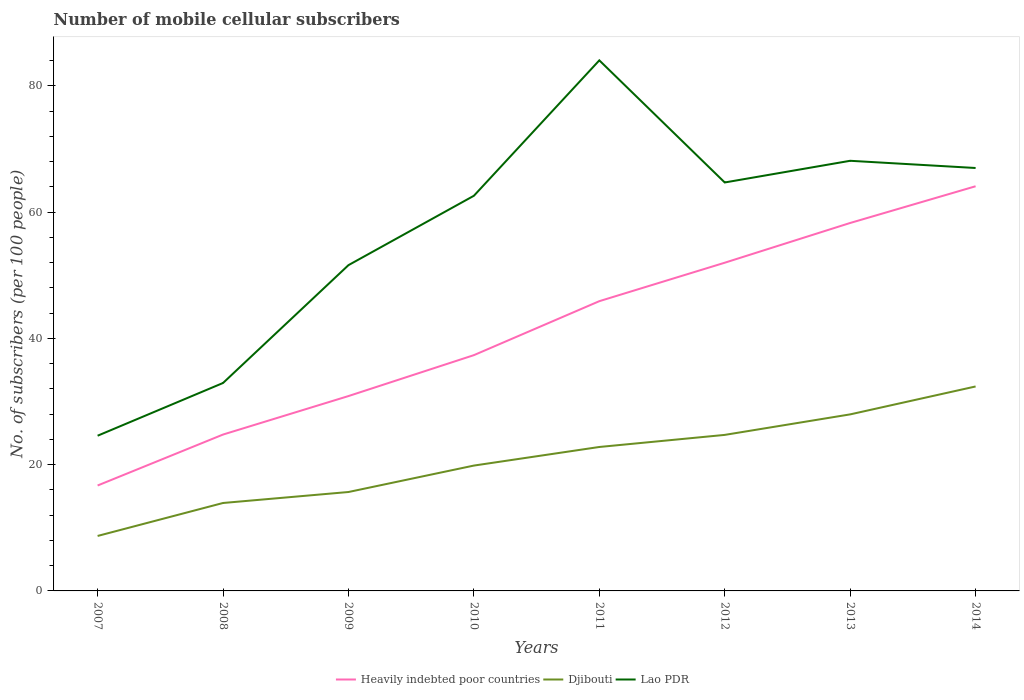Does the line corresponding to Heavily indebted poor countries intersect with the line corresponding to Lao PDR?
Your response must be concise. No. Across all years, what is the maximum number of mobile cellular subscribers in Heavily indebted poor countries?
Give a very brief answer. 16.7. What is the total number of mobile cellular subscribers in Heavily indebted poor countries in the graph?
Ensure brevity in your answer.  -39.33. What is the difference between the highest and the second highest number of mobile cellular subscribers in Djibouti?
Give a very brief answer. 23.68. What is the difference between the highest and the lowest number of mobile cellular subscribers in Heavily indebted poor countries?
Offer a terse response. 4. How many lines are there?
Your answer should be very brief. 3. How many legend labels are there?
Keep it short and to the point. 3. What is the title of the graph?
Your answer should be very brief. Number of mobile cellular subscribers. What is the label or title of the Y-axis?
Make the answer very short. No. of subscribers (per 100 people). What is the No. of subscribers (per 100 people) of Heavily indebted poor countries in 2007?
Your answer should be very brief. 16.7. What is the No. of subscribers (per 100 people) in Djibouti in 2007?
Offer a very short reply. 8.71. What is the No. of subscribers (per 100 people) of Lao PDR in 2007?
Ensure brevity in your answer.  24.59. What is the No. of subscribers (per 100 people) of Heavily indebted poor countries in 2008?
Your response must be concise. 24.77. What is the No. of subscribers (per 100 people) in Djibouti in 2008?
Your answer should be compact. 13.93. What is the No. of subscribers (per 100 people) of Lao PDR in 2008?
Provide a succinct answer. 32.94. What is the No. of subscribers (per 100 people) of Heavily indebted poor countries in 2009?
Offer a terse response. 30.87. What is the No. of subscribers (per 100 people) of Djibouti in 2009?
Keep it short and to the point. 15.67. What is the No. of subscribers (per 100 people) of Lao PDR in 2009?
Provide a succinct answer. 51.61. What is the No. of subscribers (per 100 people) in Heavily indebted poor countries in 2010?
Provide a short and direct response. 37.35. What is the No. of subscribers (per 100 people) of Djibouti in 2010?
Your answer should be very brief. 19.86. What is the No. of subscribers (per 100 people) in Lao PDR in 2010?
Provide a succinct answer. 62.59. What is the No. of subscribers (per 100 people) of Heavily indebted poor countries in 2011?
Provide a short and direct response. 45.9. What is the No. of subscribers (per 100 people) of Djibouti in 2011?
Ensure brevity in your answer.  22.8. What is the No. of subscribers (per 100 people) of Lao PDR in 2011?
Keep it short and to the point. 84.05. What is the No. of subscribers (per 100 people) of Heavily indebted poor countries in 2012?
Provide a short and direct response. 51.99. What is the No. of subscribers (per 100 people) of Djibouti in 2012?
Give a very brief answer. 24.72. What is the No. of subscribers (per 100 people) in Lao PDR in 2012?
Make the answer very short. 64.7. What is the No. of subscribers (per 100 people) of Heavily indebted poor countries in 2013?
Provide a short and direct response. 58.28. What is the No. of subscribers (per 100 people) in Djibouti in 2013?
Make the answer very short. 27.97. What is the No. of subscribers (per 100 people) of Lao PDR in 2013?
Keep it short and to the point. 68.14. What is the No. of subscribers (per 100 people) in Heavily indebted poor countries in 2014?
Give a very brief answer. 64.1. What is the No. of subscribers (per 100 people) in Djibouti in 2014?
Your answer should be very brief. 32.39. What is the No. of subscribers (per 100 people) of Lao PDR in 2014?
Provide a short and direct response. 66.99. Across all years, what is the maximum No. of subscribers (per 100 people) in Heavily indebted poor countries?
Provide a succinct answer. 64.1. Across all years, what is the maximum No. of subscribers (per 100 people) in Djibouti?
Your answer should be very brief. 32.39. Across all years, what is the maximum No. of subscribers (per 100 people) of Lao PDR?
Your response must be concise. 84.05. Across all years, what is the minimum No. of subscribers (per 100 people) of Heavily indebted poor countries?
Your answer should be very brief. 16.7. Across all years, what is the minimum No. of subscribers (per 100 people) of Djibouti?
Ensure brevity in your answer.  8.71. Across all years, what is the minimum No. of subscribers (per 100 people) in Lao PDR?
Offer a very short reply. 24.59. What is the total No. of subscribers (per 100 people) of Heavily indebted poor countries in the graph?
Offer a terse response. 329.96. What is the total No. of subscribers (per 100 people) of Djibouti in the graph?
Offer a terse response. 166.03. What is the total No. of subscribers (per 100 people) of Lao PDR in the graph?
Provide a short and direct response. 455.6. What is the difference between the No. of subscribers (per 100 people) of Heavily indebted poor countries in 2007 and that in 2008?
Ensure brevity in your answer.  -8.07. What is the difference between the No. of subscribers (per 100 people) of Djibouti in 2007 and that in 2008?
Keep it short and to the point. -5.22. What is the difference between the No. of subscribers (per 100 people) in Lao PDR in 2007 and that in 2008?
Your answer should be compact. -8.35. What is the difference between the No. of subscribers (per 100 people) in Heavily indebted poor countries in 2007 and that in 2009?
Your answer should be compact. -14.17. What is the difference between the No. of subscribers (per 100 people) of Djibouti in 2007 and that in 2009?
Your answer should be very brief. -6.96. What is the difference between the No. of subscribers (per 100 people) in Lao PDR in 2007 and that in 2009?
Make the answer very short. -27.02. What is the difference between the No. of subscribers (per 100 people) in Heavily indebted poor countries in 2007 and that in 2010?
Offer a terse response. -20.65. What is the difference between the No. of subscribers (per 100 people) of Djibouti in 2007 and that in 2010?
Make the answer very short. -11.15. What is the difference between the No. of subscribers (per 100 people) in Lao PDR in 2007 and that in 2010?
Ensure brevity in your answer.  -38.01. What is the difference between the No. of subscribers (per 100 people) in Heavily indebted poor countries in 2007 and that in 2011?
Give a very brief answer. -29.2. What is the difference between the No. of subscribers (per 100 people) of Djibouti in 2007 and that in 2011?
Keep it short and to the point. -14.1. What is the difference between the No. of subscribers (per 100 people) of Lao PDR in 2007 and that in 2011?
Give a very brief answer. -59.46. What is the difference between the No. of subscribers (per 100 people) of Heavily indebted poor countries in 2007 and that in 2012?
Provide a succinct answer. -35.29. What is the difference between the No. of subscribers (per 100 people) of Djibouti in 2007 and that in 2012?
Provide a succinct answer. -16.01. What is the difference between the No. of subscribers (per 100 people) of Lao PDR in 2007 and that in 2012?
Your answer should be very brief. -40.12. What is the difference between the No. of subscribers (per 100 people) of Heavily indebted poor countries in 2007 and that in 2013?
Provide a short and direct response. -41.59. What is the difference between the No. of subscribers (per 100 people) of Djibouti in 2007 and that in 2013?
Provide a succinct answer. -19.26. What is the difference between the No. of subscribers (per 100 people) in Lao PDR in 2007 and that in 2013?
Offer a terse response. -43.55. What is the difference between the No. of subscribers (per 100 people) of Heavily indebted poor countries in 2007 and that in 2014?
Your response must be concise. -47.4. What is the difference between the No. of subscribers (per 100 people) in Djibouti in 2007 and that in 2014?
Offer a terse response. -23.68. What is the difference between the No. of subscribers (per 100 people) of Lao PDR in 2007 and that in 2014?
Give a very brief answer. -42.41. What is the difference between the No. of subscribers (per 100 people) of Heavily indebted poor countries in 2008 and that in 2009?
Offer a terse response. -6.1. What is the difference between the No. of subscribers (per 100 people) of Djibouti in 2008 and that in 2009?
Your response must be concise. -1.74. What is the difference between the No. of subscribers (per 100 people) in Lao PDR in 2008 and that in 2009?
Ensure brevity in your answer.  -18.67. What is the difference between the No. of subscribers (per 100 people) in Heavily indebted poor countries in 2008 and that in 2010?
Make the answer very short. -12.58. What is the difference between the No. of subscribers (per 100 people) of Djibouti in 2008 and that in 2010?
Keep it short and to the point. -5.93. What is the difference between the No. of subscribers (per 100 people) of Lao PDR in 2008 and that in 2010?
Offer a very short reply. -29.66. What is the difference between the No. of subscribers (per 100 people) of Heavily indebted poor countries in 2008 and that in 2011?
Keep it short and to the point. -21.13. What is the difference between the No. of subscribers (per 100 people) of Djibouti in 2008 and that in 2011?
Offer a terse response. -8.87. What is the difference between the No. of subscribers (per 100 people) of Lao PDR in 2008 and that in 2011?
Ensure brevity in your answer.  -51.11. What is the difference between the No. of subscribers (per 100 people) in Heavily indebted poor countries in 2008 and that in 2012?
Keep it short and to the point. -27.22. What is the difference between the No. of subscribers (per 100 people) of Djibouti in 2008 and that in 2012?
Your response must be concise. -10.79. What is the difference between the No. of subscribers (per 100 people) in Lao PDR in 2008 and that in 2012?
Offer a very short reply. -31.76. What is the difference between the No. of subscribers (per 100 people) in Heavily indebted poor countries in 2008 and that in 2013?
Ensure brevity in your answer.  -33.51. What is the difference between the No. of subscribers (per 100 people) of Djibouti in 2008 and that in 2013?
Keep it short and to the point. -14.04. What is the difference between the No. of subscribers (per 100 people) of Lao PDR in 2008 and that in 2013?
Your response must be concise. -35.2. What is the difference between the No. of subscribers (per 100 people) in Heavily indebted poor countries in 2008 and that in 2014?
Ensure brevity in your answer.  -39.33. What is the difference between the No. of subscribers (per 100 people) in Djibouti in 2008 and that in 2014?
Make the answer very short. -18.46. What is the difference between the No. of subscribers (per 100 people) of Lao PDR in 2008 and that in 2014?
Your answer should be compact. -34.05. What is the difference between the No. of subscribers (per 100 people) in Heavily indebted poor countries in 2009 and that in 2010?
Provide a short and direct response. -6.48. What is the difference between the No. of subscribers (per 100 people) of Djibouti in 2009 and that in 2010?
Give a very brief answer. -4.19. What is the difference between the No. of subscribers (per 100 people) of Lao PDR in 2009 and that in 2010?
Your answer should be compact. -10.99. What is the difference between the No. of subscribers (per 100 people) in Heavily indebted poor countries in 2009 and that in 2011?
Offer a terse response. -15.03. What is the difference between the No. of subscribers (per 100 people) of Djibouti in 2009 and that in 2011?
Keep it short and to the point. -7.13. What is the difference between the No. of subscribers (per 100 people) of Lao PDR in 2009 and that in 2011?
Your answer should be very brief. -32.44. What is the difference between the No. of subscribers (per 100 people) of Heavily indebted poor countries in 2009 and that in 2012?
Provide a succinct answer. -21.12. What is the difference between the No. of subscribers (per 100 people) of Djibouti in 2009 and that in 2012?
Keep it short and to the point. -9.05. What is the difference between the No. of subscribers (per 100 people) of Lao PDR in 2009 and that in 2012?
Offer a terse response. -13.1. What is the difference between the No. of subscribers (per 100 people) of Heavily indebted poor countries in 2009 and that in 2013?
Make the answer very short. -27.42. What is the difference between the No. of subscribers (per 100 people) in Djibouti in 2009 and that in 2013?
Make the answer very short. -12.3. What is the difference between the No. of subscribers (per 100 people) of Lao PDR in 2009 and that in 2013?
Your answer should be compact. -16.53. What is the difference between the No. of subscribers (per 100 people) in Heavily indebted poor countries in 2009 and that in 2014?
Keep it short and to the point. -33.23. What is the difference between the No. of subscribers (per 100 people) of Djibouti in 2009 and that in 2014?
Make the answer very short. -16.72. What is the difference between the No. of subscribers (per 100 people) of Lao PDR in 2009 and that in 2014?
Give a very brief answer. -15.39. What is the difference between the No. of subscribers (per 100 people) in Heavily indebted poor countries in 2010 and that in 2011?
Keep it short and to the point. -8.55. What is the difference between the No. of subscribers (per 100 people) in Djibouti in 2010 and that in 2011?
Make the answer very short. -2.94. What is the difference between the No. of subscribers (per 100 people) of Lao PDR in 2010 and that in 2011?
Ensure brevity in your answer.  -21.45. What is the difference between the No. of subscribers (per 100 people) in Heavily indebted poor countries in 2010 and that in 2012?
Keep it short and to the point. -14.64. What is the difference between the No. of subscribers (per 100 people) of Djibouti in 2010 and that in 2012?
Keep it short and to the point. -4.86. What is the difference between the No. of subscribers (per 100 people) of Lao PDR in 2010 and that in 2012?
Give a very brief answer. -2.11. What is the difference between the No. of subscribers (per 100 people) of Heavily indebted poor countries in 2010 and that in 2013?
Your answer should be compact. -20.94. What is the difference between the No. of subscribers (per 100 people) in Djibouti in 2010 and that in 2013?
Provide a short and direct response. -8.11. What is the difference between the No. of subscribers (per 100 people) of Lao PDR in 2010 and that in 2013?
Make the answer very short. -5.54. What is the difference between the No. of subscribers (per 100 people) in Heavily indebted poor countries in 2010 and that in 2014?
Offer a terse response. -26.75. What is the difference between the No. of subscribers (per 100 people) of Djibouti in 2010 and that in 2014?
Offer a very short reply. -12.53. What is the difference between the No. of subscribers (per 100 people) in Lao PDR in 2010 and that in 2014?
Your answer should be compact. -4.4. What is the difference between the No. of subscribers (per 100 people) in Heavily indebted poor countries in 2011 and that in 2012?
Your response must be concise. -6.09. What is the difference between the No. of subscribers (per 100 people) of Djibouti in 2011 and that in 2012?
Offer a very short reply. -1.91. What is the difference between the No. of subscribers (per 100 people) in Lao PDR in 2011 and that in 2012?
Offer a terse response. 19.34. What is the difference between the No. of subscribers (per 100 people) in Heavily indebted poor countries in 2011 and that in 2013?
Your answer should be very brief. -12.39. What is the difference between the No. of subscribers (per 100 people) of Djibouti in 2011 and that in 2013?
Your response must be concise. -5.16. What is the difference between the No. of subscribers (per 100 people) in Lao PDR in 2011 and that in 2013?
Provide a succinct answer. 15.91. What is the difference between the No. of subscribers (per 100 people) in Heavily indebted poor countries in 2011 and that in 2014?
Make the answer very short. -18.2. What is the difference between the No. of subscribers (per 100 people) of Djibouti in 2011 and that in 2014?
Provide a succinct answer. -9.59. What is the difference between the No. of subscribers (per 100 people) of Lao PDR in 2011 and that in 2014?
Ensure brevity in your answer.  17.05. What is the difference between the No. of subscribers (per 100 people) in Heavily indebted poor countries in 2012 and that in 2013?
Keep it short and to the point. -6.3. What is the difference between the No. of subscribers (per 100 people) of Djibouti in 2012 and that in 2013?
Offer a very short reply. -3.25. What is the difference between the No. of subscribers (per 100 people) in Lao PDR in 2012 and that in 2013?
Your answer should be compact. -3.43. What is the difference between the No. of subscribers (per 100 people) of Heavily indebted poor countries in 2012 and that in 2014?
Provide a succinct answer. -12.11. What is the difference between the No. of subscribers (per 100 people) of Djibouti in 2012 and that in 2014?
Give a very brief answer. -7.67. What is the difference between the No. of subscribers (per 100 people) of Lao PDR in 2012 and that in 2014?
Ensure brevity in your answer.  -2.29. What is the difference between the No. of subscribers (per 100 people) in Heavily indebted poor countries in 2013 and that in 2014?
Keep it short and to the point. -5.82. What is the difference between the No. of subscribers (per 100 people) in Djibouti in 2013 and that in 2014?
Provide a succinct answer. -4.42. What is the difference between the No. of subscribers (per 100 people) of Lao PDR in 2013 and that in 2014?
Offer a very short reply. 1.14. What is the difference between the No. of subscribers (per 100 people) of Heavily indebted poor countries in 2007 and the No. of subscribers (per 100 people) of Djibouti in 2008?
Give a very brief answer. 2.77. What is the difference between the No. of subscribers (per 100 people) in Heavily indebted poor countries in 2007 and the No. of subscribers (per 100 people) in Lao PDR in 2008?
Your answer should be very brief. -16.24. What is the difference between the No. of subscribers (per 100 people) of Djibouti in 2007 and the No. of subscribers (per 100 people) of Lao PDR in 2008?
Keep it short and to the point. -24.23. What is the difference between the No. of subscribers (per 100 people) in Heavily indebted poor countries in 2007 and the No. of subscribers (per 100 people) in Djibouti in 2009?
Make the answer very short. 1.03. What is the difference between the No. of subscribers (per 100 people) of Heavily indebted poor countries in 2007 and the No. of subscribers (per 100 people) of Lao PDR in 2009?
Keep it short and to the point. -34.91. What is the difference between the No. of subscribers (per 100 people) in Djibouti in 2007 and the No. of subscribers (per 100 people) in Lao PDR in 2009?
Give a very brief answer. -42.9. What is the difference between the No. of subscribers (per 100 people) in Heavily indebted poor countries in 2007 and the No. of subscribers (per 100 people) in Djibouti in 2010?
Provide a succinct answer. -3.16. What is the difference between the No. of subscribers (per 100 people) of Heavily indebted poor countries in 2007 and the No. of subscribers (per 100 people) of Lao PDR in 2010?
Offer a terse response. -45.9. What is the difference between the No. of subscribers (per 100 people) in Djibouti in 2007 and the No. of subscribers (per 100 people) in Lao PDR in 2010?
Your response must be concise. -53.89. What is the difference between the No. of subscribers (per 100 people) of Heavily indebted poor countries in 2007 and the No. of subscribers (per 100 people) of Djibouti in 2011?
Your answer should be compact. -6.1. What is the difference between the No. of subscribers (per 100 people) in Heavily indebted poor countries in 2007 and the No. of subscribers (per 100 people) in Lao PDR in 2011?
Keep it short and to the point. -67.35. What is the difference between the No. of subscribers (per 100 people) in Djibouti in 2007 and the No. of subscribers (per 100 people) in Lao PDR in 2011?
Ensure brevity in your answer.  -75.34. What is the difference between the No. of subscribers (per 100 people) of Heavily indebted poor countries in 2007 and the No. of subscribers (per 100 people) of Djibouti in 2012?
Your answer should be compact. -8.02. What is the difference between the No. of subscribers (per 100 people) in Heavily indebted poor countries in 2007 and the No. of subscribers (per 100 people) in Lao PDR in 2012?
Provide a succinct answer. -48. What is the difference between the No. of subscribers (per 100 people) in Djibouti in 2007 and the No. of subscribers (per 100 people) in Lao PDR in 2012?
Offer a terse response. -56. What is the difference between the No. of subscribers (per 100 people) of Heavily indebted poor countries in 2007 and the No. of subscribers (per 100 people) of Djibouti in 2013?
Ensure brevity in your answer.  -11.27. What is the difference between the No. of subscribers (per 100 people) in Heavily indebted poor countries in 2007 and the No. of subscribers (per 100 people) in Lao PDR in 2013?
Give a very brief answer. -51.44. What is the difference between the No. of subscribers (per 100 people) in Djibouti in 2007 and the No. of subscribers (per 100 people) in Lao PDR in 2013?
Provide a short and direct response. -59.43. What is the difference between the No. of subscribers (per 100 people) of Heavily indebted poor countries in 2007 and the No. of subscribers (per 100 people) of Djibouti in 2014?
Give a very brief answer. -15.69. What is the difference between the No. of subscribers (per 100 people) of Heavily indebted poor countries in 2007 and the No. of subscribers (per 100 people) of Lao PDR in 2014?
Offer a very short reply. -50.29. What is the difference between the No. of subscribers (per 100 people) of Djibouti in 2007 and the No. of subscribers (per 100 people) of Lao PDR in 2014?
Your response must be concise. -58.29. What is the difference between the No. of subscribers (per 100 people) of Heavily indebted poor countries in 2008 and the No. of subscribers (per 100 people) of Djibouti in 2009?
Keep it short and to the point. 9.1. What is the difference between the No. of subscribers (per 100 people) in Heavily indebted poor countries in 2008 and the No. of subscribers (per 100 people) in Lao PDR in 2009?
Offer a very short reply. -26.84. What is the difference between the No. of subscribers (per 100 people) in Djibouti in 2008 and the No. of subscribers (per 100 people) in Lao PDR in 2009?
Your answer should be very brief. -37.68. What is the difference between the No. of subscribers (per 100 people) of Heavily indebted poor countries in 2008 and the No. of subscribers (per 100 people) of Djibouti in 2010?
Provide a succinct answer. 4.91. What is the difference between the No. of subscribers (per 100 people) of Heavily indebted poor countries in 2008 and the No. of subscribers (per 100 people) of Lao PDR in 2010?
Provide a succinct answer. -37.82. What is the difference between the No. of subscribers (per 100 people) of Djibouti in 2008 and the No. of subscribers (per 100 people) of Lao PDR in 2010?
Provide a short and direct response. -48.66. What is the difference between the No. of subscribers (per 100 people) in Heavily indebted poor countries in 2008 and the No. of subscribers (per 100 people) in Djibouti in 2011?
Keep it short and to the point. 1.97. What is the difference between the No. of subscribers (per 100 people) in Heavily indebted poor countries in 2008 and the No. of subscribers (per 100 people) in Lao PDR in 2011?
Your answer should be compact. -59.27. What is the difference between the No. of subscribers (per 100 people) of Djibouti in 2008 and the No. of subscribers (per 100 people) of Lao PDR in 2011?
Your answer should be very brief. -70.12. What is the difference between the No. of subscribers (per 100 people) in Heavily indebted poor countries in 2008 and the No. of subscribers (per 100 people) in Djibouti in 2012?
Ensure brevity in your answer.  0.05. What is the difference between the No. of subscribers (per 100 people) of Heavily indebted poor countries in 2008 and the No. of subscribers (per 100 people) of Lao PDR in 2012?
Your answer should be compact. -39.93. What is the difference between the No. of subscribers (per 100 people) in Djibouti in 2008 and the No. of subscribers (per 100 people) in Lao PDR in 2012?
Your answer should be compact. -50.77. What is the difference between the No. of subscribers (per 100 people) of Heavily indebted poor countries in 2008 and the No. of subscribers (per 100 people) of Djibouti in 2013?
Your response must be concise. -3.2. What is the difference between the No. of subscribers (per 100 people) of Heavily indebted poor countries in 2008 and the No. of subscribers (per 100 people) of Lao PDR in 2013?
Ensure brevity in your answer.  -43.37. What is the difference between the No. of subscribers (per 100 people) in Djibouti in 2008 and the No. of subscribers (per 100 people) in Lao PDR in 2013?
Ensure brevity in your answer.  -54.21. What is the difference between the No. of subscribers (per 100 people) of Heavily indebted poor countries in 2008 and the No. of subscribers (per 100 people) of Djibouti in 2014?
Provide a short and direct response. -7.62. What is the difference between the No. of subscribers (per 100 people) of Heavily indebted poor countries in 2008 and the No. of subscribers (per 100 people) of Lao PDR in 2014?
Offer a very short reply. -42.22. What is the difference between the No. of subscribers (per 100 people) of Djibouti in 2008 and the No. of subscribers (per 100 people) of Lao PDR in 2014?
Make the answer very short. -53.06. What is the difference between the No. of subscribers (per 100 people) in Heavily indebted poor countries in 2009 and the No. of subscribers (per 100 people) in Djibouti in 2010?
Ensure brevity in your answer.  11.01. What is the difference between the No. of subscribers (per 100 people) in Heavily indebted poor countries in 2009 and the No. of subscribers (per 100 people) in Lao PDR in 2010?
Offer a terse response. -31.73. What is the difference between the No. of subscribers (per 100 people) of Djibouti in 2009 and the No. of subscribers (per 100 people) of Lao PDR in 2010?
Your answer should be very brief. -46.93. What is the difference between the No. of subscribers (per 100 people) of Heavily indebted poor countries in 2009 and the No. of subscribers (per 100 people) of Djibouti in 2011?
Give a very brief answer. 8.07. What is the difference between the No. of subscribers (per 100 people) of Heavily indebted poor countries in 2009 and the No. of subscribers (per 100 people) of Lao PDR in 2011?
Keep it short and to the point. -53.18. What is the difference between the No. of subscribers (per 100 people) in Djibouti in 2009 and the No. of subscribers (per 100 people) in Lao PDR in 2011?
Ensure brevity in your answer.  -68.38. What is the difference between the No. of subscribers (per 100 people) of Heavily indebted poor countries in 2009 and the No. of subscribers (per 100 people) of Djibouti in 2012?
Your response must be concise. 6.15. What is the difference between the No. of subscribers (per 100 people) in Heavily indebted poor countries in 2009 and the No. of subscribers (per 100 people) in Lao PDR in 2012?
Your answer should be compact. -33.83. What is the difference between the No. of subscribers (per 100 people) in Djibouti in 2009 and the No. of subscribers (per 100 people) in Lao PDR in 2012?
Provide a succinct answer. -49.03. What is the difference between the No. of subscribers (per 100 people) of Heavily indebted poor countries in 2009 and the No. of subscribers (per 100 people) of Djibouti in 2013?
Give a very brief answer. 2.9. What is the difference between the No. of subscribers (per 100 people) in Heavily indebted poor countries in 2009 and the No. of subscribers (per 100 people) in Lao PDR in 2013?
Make the answer very short. -37.27. What is the difference between the No. of subscribers (per 100 people) of Djibouti in 2009 and the No. of subscribers (per 100 people) of Lao PDR in 2013?
Ensure brevity in your answer.  -52.47. What is the difference between the No. of subscribers (per 100 people) of Heavily indebted poor countries in 2009 and the No. of subscribers (per 100 people) of Djibouti in 2014?
Your answer should be compact. -1.52. What is the difference between the No. of subscribers (per 100 people) in Heavily indebted poor countries in 2009 and the No. of subscribers (per 100 people) in Lao PDR in 2014?
Your response must be concise. -36.13. What is the difference between the No. of subscribers (per 100 people) in Djibouti in 2009 and the No. of subscribers (per 100 people) in Lao PDR in 2014?
Keep it short and to the point. -51.32. What is the difference between the No. of subscribers (per 100 people) in Heavily indebted poor countries in 2010 and the No. of subscribers (per 100 people) in Djibouti in 2011?
Offer a terse response. 14.55. What is the difference between the No. of subscribers (per 100 people) of Heavily indebted poor countries in 2010 and the No. of subscribers (per 100 people) of Lao PDR in 2011?
Ensure brevity in your answer.  -46.7. What is the difference between the No. of subscribers (per 100 people) in Djibouti in 2010 and the No. of subscribers (per 100 people) in Lao PDR in 2011?
Offer a very short reply. -64.19. What is the difference between the No. of subscribers (per 100 people) of Heavily indebted poor countries in 2010 and the No. of subscribers (per 100 people) of Djibouti in 2012?
Offer a terse response. 12.63. What is the difference between the No. of subscribers (per 100 people) in Heavily indebted poor countries in 2010 and the No. of subscribers (per 100 people) in Lao PDR in 2012?
Offer a terse response. -27.35. What is the difference between the No. of subscribers (per 100 people) of Djibouti in 2010 and the No. of subscribers (per 100 people) of Lao PDR in 2012?
Your response must be concise. -44.85. What is the difference between the No. of subscribers (per 100 people) of Heavily indebted poor countries in 2010 and the No. of subscribers (per 100 people) of Djibouti in 2013?
Provide a succinct answer. 9.38. What is the difference between the No. of subscribers (per 100 people) in Heavily indebted poor countries in 2010 and the No. of subscribers (per 100 people) in Lao PDR in 2013?
Ensure brevity in your answer.  -30.79. What is the difference between the No. of subscribers (per 100 people) in Djibouti in 2010 and the No. of subscribers (per 100 people) in Lao PDR in 2013?
Your answer should be compact. -48.28. What is the difference between the No. of subscribers (per 100 people) of Heavily indebted poor countries in 2010 and the No. of subscribers (per 100 people) of Djibouti in 2014?
Provide a succinct answer. 4.96. What is the difference between the No. of subscribers (per 100 people) of Heavily indebted poor countries in 2010 and the No. of subscribers (per 100 people) of Lao PDR in 2014?
Provide a short and direct response. -29.65. What is the difference between the No. of subscribers (per 100 people) of Djibouti in 2010 and the No. of subscribers (per 100 people) of Lao PDR in 2014?
Provide a short and direct response. -47.14. What is the difference between the No. of subscribers (per 100 people) in Heavily indebted poor countries in 2011 and the No. of subscribers (per 100 people) in Djibouti in 2012?
Offer a terse response. 21.18. What is the difference between the No. of subscribers (per 100 people) of Heavily indebted poor countries in 2011 and the No. of subscribers (per 100 people) of Lao PDR in 2012?
Offer a very short reply. -18.8. What is the difference between the No. of subscribers (per 100 people) in Djibouti in 2011 and the No. of subscribers (per 100 people) in Lao PDR in 2012?
Ensure brevity in your answer.  -41.9. What is the difference between the No. of subscribers (per 100 people) in Heavily indebted poor countries in 2011 and the No. of subscribers (per 100 people) in Djibouti in 2013?
Your answer should be compact. 17.93. What is the difference between the No. of subscribers (per 100 people) of Heavily indebted poor countries in 2011 and the No. of subscribers (per 100 people) of Lao PDR in 2013?
Make the answer very short. -22.24. What is the difference between the No. of subscribers (per 100 people) of Djibouti in 2011 and the No. of subscribers (per 100 people) of Lao PDR in 2013?
Your answer should be very brief. -45.33. What is the difference between the No. of subscribers (per 100 people) in Heavily indebted poor countries in 2011 and the No. of subscribers (per 100 people) in Djibouti in 2014?
Give a very brief answer. 13.51. What is the difference between the No. of subscribers (per 100 people) in Heavily indebted poor countries in 2011 and the No. of subscribers (per 100 people) in Lao PDR in 2014?
Give a very brief answer. -21.09. What is the difference between the No. of subscribers (per 100 people) of Djibouti in 2011 and the No. of subscribers (per 100 people) of Lao PDR in 2014?
Offer a terse response. -44.19. What is the difference between the No. of subscribers (per 100 people) in Heavily indebted poor countries in 2012 and the No. of subscribers (per 100 people) in Djibouti in 2013?
Your answer should be very brief. 24.02. What is the difference between the No. of subscribers (per 100 people) of Heavily indebted poor countries in 2012 and the No. of subscribers (per 100 people) of Lao PDR in 2013?
Provide a short and direct response. -16.15. What is the difference between the No. of subscribers (per 100 people) of Djibouti in 2012 and the No. of subscribers (per 100 people) of Lao PDR in 2013?
Offer a very short reply. -43.42. What is the difference between the No. of subscribers (per 100 people) of Heavily indebted poor countries in 2012 and the No. of subscribers (per 100 people) of Djibouti in 2014?
Give a very brief answer. 19.6. What is the difference between the No. of subscribers (per 100 people) in Heavily indebted poor countries in 2012 and the No. of subscribers (per 100 people) in Lao PDR in 2014?
Provide a succinct answer. -15. What is the difference between the No. of subscribers (per 100 people) in Djibouti in 2012 and the No. of subscribers (per 100 people) in Lao PDR in 2014?
Provide a short and direct response. -42.28. What is the difference between the No. of subscribers (per 100 people) in Heavily indebted poor countries in 2013 and the No. of subscribers (per 100 people) in Djibouti in 2014?
Offer a very short reply. 25.9. What is the difference between the No. of subscribers (per 100 people) of Heavily indebted poor countries in 2013 and the No. of subscribers (per 100 people) of Lao PDR in 2014?
Ensure brevity in your answer.  -8.71. What is the difference between the No. of subscribers (per 100 people) in Djibouti in 2013 and the No. of subscribers (per 100 people) in Lao PDR in 2014?
Make the answer very short. -39.03. What is the average No. of subscribers (per 100 people) of Heavily indebted poor countries per year?
Keep it short and to the point. 41.25. What is the average No. of subscribers (per 100 people) in Djibouti per year?
Your response must be concise. 20.75. What is the average No. of subscribers (per 100 people) in Lao PDR per year?
Ensure brevity in your answer.  56.95. In the year 2007, what is the difference between the No. of subscribers (per 100 people) of Heavily indebted poor countries and No. of subscribers (per 100 people) of Djibouti?
Offer a very short reply. 7.99. In the year 2007, what is the difference between the No. of subscribers (per 100 people) in Heavily indebted poor countries and No. of subscribers (per 100 people) in Lao PDR?
Make the answer very short. -7.89. In the year 2007, what is the difference between the No. of subscribers (per 100 people) of Djibouti and No. of subscribers (per 100 people) of Lao PDR?
Give a very brief answer. -15.88. In the year 2008, what is the difference between the No. of subscribers (per 100 people) of Heavily indebted poor countries and No. of subscribers (per 100 people) of Djibouti?
Keep it short and to the point. 10.84. In the year 2008, what is the difference between the No. of subscribers (per 100 people) of Heavily indebted poor countries and No. of subscribers (per 100 people) of Lao PDR?
Make the answer very short. -8.17. In the year 2008, what is the difference between the No. of subscribers (per 100 people) of Djibouti and No. of subscribers (per 100 people) of Lao PDR?
Your answer should be compact. -19.01. In the year 2009, what is the difference between the No. of subscribers (per 100 people) in Heavily indebted poor countries and No. of subscribers (per 100 people) in Djibouti?
Keep it short and to the point. 15.2. In the year 2009, what is the difference between the No. of subscribers (per 100 people) of Heavily indebted poor countries and No. of subscribers (per 100 people) of Lao PDR?
Offer a very short reply. -20.74. In the year 2009, what is the difference between the No. of subscribers (per 100 people) of Djibouti and No. of subscribers (per 100 people) of Lao PDR?
Your answer should be compact. -35.94. In the year 2010, what is the difference between the No. of subscribers (per 100 people) in Heavily indebted poor countries and No. of subscribers (per 100 people) in Djibouti?
Ensure brevity in your answer.  17.49. In the year 2010, what is the difference between the No. of subscribers (per 100 people) of Heavily indebted poor countries and No. of subscribers (per 100 people) of Lao PDR?
Your response must be concise. -25.25. In the year 2010, what is the difference between the No. of subscribers (per 100 people) of Djibouti and No. of subscribers (per 100 people) of Lao PDR?
Offer a terse response. -42.74. In the year 2011, what is the difference between the No. of subscribers (per 100 people) of Heavily indebted poor countries and No. of subscribers (per 100 people) of Djibouti?
Keep it short and to the point. 23.1. In the year 2011, what is the difference between the No. of subscribers (per 100 people) of Heavily indebted poor countries and No. of subscribers (per 100 people) of Lao PDR?
Ensure brevity in your answer.  -38.15. In the year 2011, what is the difference between the No. of subscribers (per 100 people) of Djibouti and No. of subscribers (per 100 people) of Lao PDR?
Your answer should be compact. -61.24. In the year 2012, what is the difference between the No. of subscribers (per 100 people) of Heavily indebted poor countries and No. of subscribers (per 100 people) of Djibouti?
Ensure brevity in your answer.  27.27. In the year 2012, what is the difference between the No. of subscribers (per 100 people) in Heavily indebted poor countries and No. of subscribers (per 100 people) in Lao PDR?
Offer a terse response. -12.71. In the year 2012, what is the difference between the No. of subscribers (per 100 people) in Djibouti and No. of subscribers (per 100 people) in Lao PDR?
Your answer should be very brief. -39.99. In the year 2013, what is the difference between the No. of subscribers (per 100 people) of Heavily indebted poor countries and No. of subscribers (per 100 people) of Djibouti?
Your response must be concise. 30.32. In the year 2013, what is the difference between the No. of subscribers (per 100 people) of Heavily indebted poor countries and No. of subscribers (per 100 people) of Lao PDR?
Your response must be concise. -9.85. In the year 2013, what is the difference between the No. of subscribers (per 100 people) of Djibouti and No. of subscribers (per 100 people) of Lao PDR?
Offer a very short reply. -40.17. In the year 2014, what is the difference between the No. of subscribers (per 100 people) of Heavily indebted poor countries and No. of subscribers (per 100 people) of Djibouti?
Offer a very short reply. 31.72. In the year 2014, what is the difference between the No. of subscribers (per 100 people) in Heavily indebted poor countries and No. of subscribers (per 100 people) in Lao PDR?
Give a very brief answer. -2.89. In the year 2014, what is the difference between the No. of subscribers (per 100 people) of Djibouti and No. of subscribers (per 100 people) of Lao PDR?
Your answer should be very brief. -34.61. What is the ratio of the No. of subscribers (per 100 people) in Heavily indebted poor countries in 2007 to that in 2008?
Offer a very short reply. 0.67. What is the ratio of the No. of subscribers (per 100 people) of Lao PDR in 2007 to that in 2008?
Your answer should be very brief. 0.75. What is the ratio of the No. of subscribers (per 100 people) of Heavily indebted poor countries in 2007 to that in 2009?
Provide a succinct answer. 0.54. What is the ratio of the No. of subscribers (per 100 people) in Djibouti in 2007 to that in 2009?
Your answer should be very brief. 0.56. What is the ratio of the No. of subscribers (per 100 people) of Lao PDR in 2007 to that in 2009?
Give a very brief answer. 0.48. What is the ratio of the No. of subscribers (per 100 people) of Heavily indebted poor countries in 2007 to that in 2010?
Ensure brevity in your answer.  0.45. What is the ratio of the No. of subscribers (per 100 people) in Djibouti in 2007 to that in 2010?
Make the answer very short. 0.44. What is the ratio of the No. of subscribers (per 100 people) in Lao PDR in 2007 to that in 2010?
Provide a succinct answer. 0.39. What is the ratio of the No. of subscribers (per 100 people) of Heavily indebted poor countries in 2007 to that in 2011?
Your response must be concise. 0.36. What is the ratio of the No. of subscribers (per 100 people) of Djibouti in 2007 to that in 2011?
Offer a very short reply. 0.38. What is the ratio of the No. of subscribers (per 100 people) in Lao PDR in 2007 to that in 2011?
Offer a terse response. 0.29. What is the ratio of the No. of subscribers (per 100 people) of Heavily indebted poor countries in 2007 to that in 2012?
Ensure brevity in your answer.  0.32. What is the ratio of the No. of subscribers (per 100 people) of Djibouti in 2007 to that in 2012?
Offer a terse response. 0.35. What is the ratio of the No. of subscribers (per 100 people) in Lao PDR in 2007 to that in 2012?
Your answer should be very brief. 0.38. What is the ratio of the No. of subscribers (per 100 people) of Heavily indebted poor countries in 2007 to that in 2013?
Your answer should be compact. 0.29. What is the ratio of the No. of subscribers (per 100 people) in Djibouti in 2007 to that in 2013?
Provide a short and direct response. 0.31. What is the ratio of the No. of subscribers (per 100 people) of Lao PDR in 2007 to that in 2013?
Provide a succinct answer. 0.36. What is the ratio of the No. of subscribers (per 100 people) of Heavily indebted poor countries in 2007 to that in 2014?
Your answer should be very brief. 0.26. What is the ratio of the No. of subscribers (per 100 people) of Djibouti in 2007 to that in 2014?
Your response must be concise. 0.27. What is the ratio of the No. of subscribers (per 100 people) in Lao PDR in 2007 to that in 2014?
Your answer should be very brief. 0.37. What is the ratio of the No. of subscribers (per 100 people) in Heavily indebted poor countries in 2008 to that in 2009?
Offer a very short reply. 0.8. What is the ratio of the No. of subscribers (per 100 people) in Djibouti in 2008 to that in 2009?
Your answer should be compact. 0.89. What is the ratio of the No. of subscribers (per 100 people) in Lao PDR in 2008 to that in 2009?
Your answer should be very brief. 0.64. What is the ratio of the No. of subscribers (per 100 people) of Heavily indebted poor countries in 2008 to that in 2010?
Offer a very short reply. 0.66. What is the ratio of the No. of subscribers (per 100 people) of Djibouti in 2008 to that in 2010?
Your response must be concise. 0.7. What is the ratio of the No. of subscribers (per 100 people) in Lao PDR in 2008 to that in 2010?
Provide a succinct answer. 0.53. What is the ratio of the No. of subscribers (per 100 people) in Heavily indebted poor countries in 2008 to that in 2011?
Keep it short and to the point. 0.54. What is the ratio of the No. of subscribers (per 100 people) in Djibouti in 2008 to that in 2011?
Your answer should be very brief. 0.61. What is the ratio of the No. of subscribers (per 100 people) of Lao PDR in 2008 to that in 2011?
Your answer should be very brief. 0.39. What is the ratio of the No. of subscribers (per 100 people) of Heavily indebted poor countries in 2008 to that in 2012?
Your answer should be very brief. 0.48. What is the ratio of the No. of subscribers (per 100 people) in Djibouti in 2008 to that in 2012?
Keep it short and to the point. 0.56. What is the ratio of the No. of subscribers (per 100 people) in Lao PDR in 2008 to that in 2012?
Your answer should be compact. 0.51. What is the ratio of the No. of subscribers (per 100 people) in Heavily indebted poor countries in 2008 to that in 2013?
Provide a short and direct response. 0.42. What is the ratio of the No. of subscribers (per 100 people) of Djibouti in 2008 to that in 2013?
Your answer should be compact. 0.5. What is the ratio of the No. of subscribers (per 100 people) of Lao PDR in 2008 to that in 2013?
Ensure brevity in your answer.  0.48. What is the ratio of the No. of subscribers (per 100 people) in Heavily indebted poor countries in 2008 to that in 2014?
Make the answer very short. 0.39. What is the ratio of the No. of subscribers (per 100 people) of Djibouti in 2008 to that in 2014?
Ensure brevity in your answer.  0.43. What is the ratio of the No. of subscribers (per 100 people) of Lao PDR in 2008 to that in 2014?
Ensure brevity in your answer.  0.49. What is the ratio of the No. of subscribers (per 100 people) in Heavily indebted poor countries in 2009 to that in 2010?
Make the answer very short. 0.83. What is the ratio of the No. of subscribers (per 100 people) in Djibouti in 2009 to that in 2010?
Make the answer very short. 0.79. What is the ratio of the No. of subscribers (per 100 people) in Lao PDR in 2009 to that in 2010?
Keep it short and to the point. 0.82. What is the ratio of the No. of subscribers (per 100 people) in Heavily indebted poor countries in 2009 to that in 2011?
Keep it short and to the point. 0.67. What is the ratio of the No. of subscribers (per 100 people) in Djibouti in 2009 to that in 2011?
Your answer should be compact. 0.69. What is the ratio of the No. of subscribers (per 100 people) in Lao PDR in 2009 to that in 2011?
Provide a succinct answer. 0.61. What is the ratio of the No. of subscribers (per 100 people) in Heavily indebted poor countries in 2009 to that in 2012?
Give a very brief answer. 0.59. What is the ratio of the No. of subscribers (per 100 people) in Djibouti in 2009 to that in 2012?
Your answer should be compact. 0.63. What is the ratio of the No. of subscribers (per 100 people) in Lao PDR in 2009 to that in 2012?
Give a very brief answer. 0.8. What is the ratio of the No. of subscribers (per 100 people) in Heavily indebted poor countries in 2009 to that in 2013?
Give a very brief answer. 0.53. What is the ratio of the No. of subscribers (per 100 people) in Djibouti in 2009 to that in 2013?
Offer a terse response. 0.56. What is the ratio of the No. of subscribers (per 100 people) in Lao PDR in 2009 to that in 2013?
Your answer should be compact. 0.76. What is the ratio of the No. of subscribers (per 100 people) of Heavily indebted poor countries in 2009 to that in 2014?
Make the answer very short. 0.48. What is the ratio of the No. of subscribers (per 100 people) in Djibouti in 2009 to that in 2014?
Ensure brevity in your answer.  0.48. What is the ratio of the No. of subscribers (per 100 people) of Lao PDR in 2009 to that in 2014?
Keep it short and to the point. 0.77. What is the ratio of the No. of subscribers (per 100 people) of Heavily indebted poor countries in 2010 to that in 2011?
Ensure brevity in your answer.  0.81. What is the ratio of the No. of subscribers (per 100 people) of Djibouti in 2010 to that in 2011?
Provide a short and direct response. 0.87. What is the ratio of the No. of subscribers (per 100 people) of Lao PDR in 2010 to that in 2011?
Your response must be concise. 0.74. What is the ratio of the No. of subscribers (per 100 people) in Heavily indebted poor countries in 2010 to that in 2012?
Your answer should be compact. 0.72. What is the ratio of the No. of subscribers (per 100 people) in Djibouti in 2010 to that in 2012?
Provide a succinct answer. 0.8. What is the ratio of the No. of subscribers (per 100 people) in Lao PDR in 2010 to that in 2012?
Your answer should be compact. 0.97. What is the ratio of the No. of subscribers (per 100 people) of Heavily indebted poor countries in 2010 to that in 2013?
Offer a terse response. 0.64. What is the ratio of the No. of subscribers (per 100 people) in Djibouti in 2010 to that in 2013?
Offer a very short reply. 0.71. What is the ratio of the No. of subscribers (per 100 people) of Lao PDR in 2010 to that in 2013?
Make the answer very short. 0.92. What is the ratio of the No. of subscribers (per 100 people) of Heavily indebted poor countries in 2010 to that in 2014?
Provide a succinct answer. 0.58. What is the ratio of the No. of subscribers (per 100 people) in Djibouti in 2010 to that in 2014?
Ensure brevity in your answer.  0.61. What is the ratio of the No. of subscribers (per 100 people) of Lao PDR in 2010 to that in 2014?
Provide a succinct answer. 0.93. What is the ratio of the No. of subscribers (per 100 people) of Heavily indebted poor countries in 2011 to that in 2012?
Offer a terse response. 0.88. What is the ratio of the No. of subscribers (per 100 people) in Djibouti in 2011 to that in 2012?
Provide a short and direct response. 0.92. What is the ratio of the No. of subscribers (per 100 people) of Lao PDR in 2011 to that in 2012?
Your answer should be compact. 1.3. What is the ratio of the No. of subscribers (per 100 people) of Heavily indebted poor countries in 2011 to that in 2013?
Offer a terse response. 0.79. What is the ratio of the No. of subscribers (per 100 people) in Djibouti in 2011 to that in 2013?
Keep it short and to the point. 0.82. What is the ratio of the No. of subscribers (per 100 people) of Lao PDR in 2011 to that in 2013?
Offer a terse response. 1.23. What is the ratio of the No. of subscribers (per 100 people) of Heavily indebted poor countries in 2011 to that in 2014?
Give a very brief answer. 0.72. What is the ratio of the No. of subscribers (per 100 people) in Djibouti in 2011 to that in 2014?
Provide a short and direct response. 0.7. What is the ratio of the No. of subscribers (per 100 people) of Lao PDR in 2011 to that in 2014?
Offer a terse response. 1.25. What is the ratio of the No. of subscribers (per 100 people) in Heavily indebted poor countries in 2012 to that in 2013?
Provide a succinct answer. 0.89. What is the ratio of the No. of subscribers (per 100 people) of Djibouti in 2012 to that in 2013?
Provide a short and direct response. 0.88. What is the ratio of the No. of subscribers (per 100 people) in Lao PDR in 2012 to that in 2013?
Provide a short and direct response. 0.95. What is the ratio of the No. of subscribers (per 100 people) of Heavily indebted poor countries in 2012 to that in 2014?
Your answer should be very brief. 0.81. What is the ratio of the No. of subscribers (per 100 people) in Djibouti in 2012 to that in 2014?
Offer a terse response. 0.76. What is the ratio of the No. of subscribers (per 100 people) of Lao PDR in 2012 to that in 2014?
Make the answer very short. 0.97. What is the ratio of the No. of subscribers (per 100 people) of Heavily indebted poor countries in 2013 to that in 2014?
Ensure brevity in your answer.  0.91. What is the ratio of the No. of subscribers (per 100 people) of Djibouti in 2013 to that in 2014?
Ensure brevity in your answer.  0.86. What is the ratio of the No. of subscribers (per 100 people) of Lao PDR in 2013 to that in 2014?
Give a very brief answer. 1.02. What is the difference between the highest and the second highest No. of subscribers (per 100 people) in Heavily indebted poor countries?
Ensure brevity in your answer.  5.82. What is the difference between the highest and the second highest No. of subscribers (per 100 people) of Djibouti?
Provide a short and direct response. 4.42. What is the difference between the highest and the second highest No. of subscribers (per 100 people) in Lao PDR?
Ensure brevity in your answer.  15.91. What is the difference between the highest and the lowest No. of subscribers (per 100 people) of Heavily indebted poor countries?
Offer a terse response. 47.4. What is the difference between the highest and the lowest No. of subscribers (per 100 people) in Djibouti?
Give a very brief answer. 23.68. What is the difference between the highest and the lowest No. of subscribers (per 100 people) of Lao PDR?
Keep it short and to the point. 59.46. 